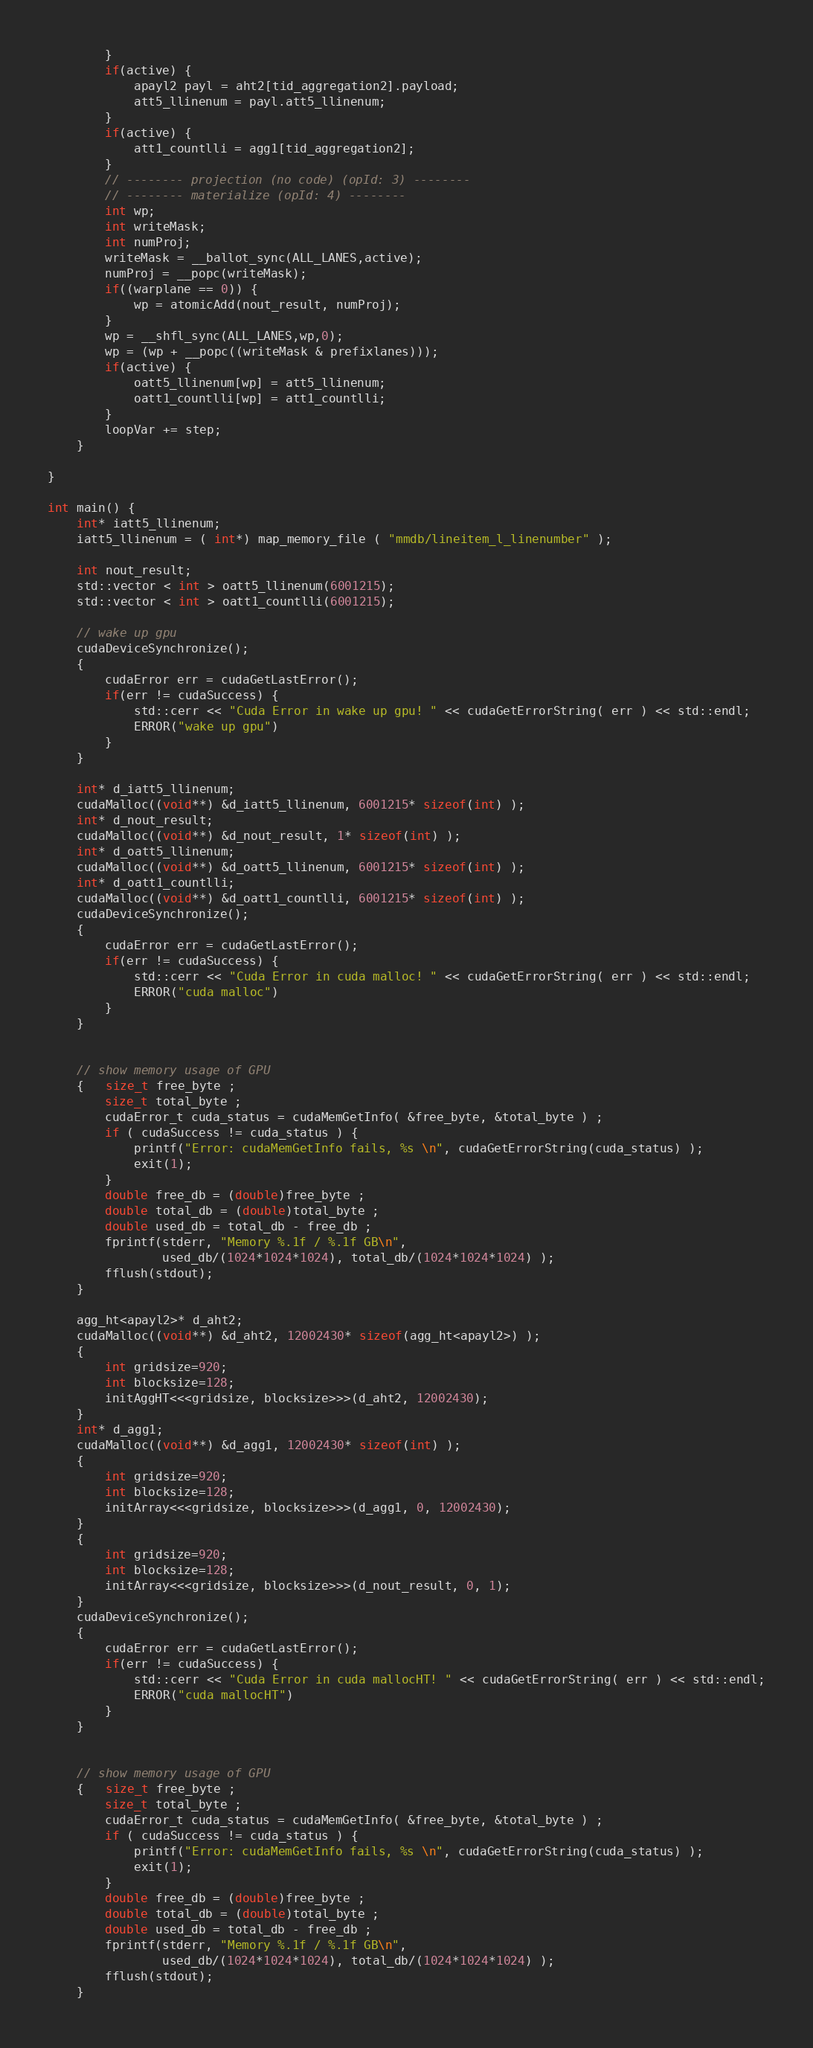Convert code to text. <code><loc_0><loc_0><loc_500><loc_500><_Cuda_>        }
        if(active) {
            apayl2 payl = aht2[tid_aggregation2].payload;
            att5_llinenum = payl.att5_llinenum;
        }
        if(active) {
            att1_countlli = agg1[tid_aggregation2];
        }
        // -------- projection (no code) (opId: 3) --------
        // -------- materialize (opId: 4) --------
        int wp;
        int writeMask;
        int numProj;
        writeMask = __ballot_sync(ALL_LANES,active);
        numProj = __popc(writeMask);
        if((warplane == 0)) {
            wp = atomicAdd(nout_result, numProj);
        }
        wp = __shfl_sync(ALL_LANES,wp,0);
        wp = (wp + __popc((writeMask & prefixlanes)));
        if(active) {
            oatt5_llinenum[wp] = att5_llinenum;
            oatt1_countlli[wp] = att1_countlli;
        }
        loopVar += step;
    }

}

int main() {
    int* iatt5_llinenum;
    iatt5_llinenum = ( int*) map_memory_file ( "mmdb/lineitem_l_linenumber" );

    int nout_result;
    std::vector < int > oatt5_llinenum(6001215);
    std::vector < int > oatt1_countlli(6001215);

    // wake up gpu
    cudaDeviceSynchronize();
    {
        cudaError err = cudaGetLastError();
        if(err != cudaSuccess) {
            std::cerr << "Cuda Error in wake up gpu! " << cudaGetErrorString( err ) << std::endl;
            ERROR("wake up gpu")
        }
    }

    int* d_iatt5_llinenum;
    cudaMalloc((void**) &d_iatt5_llinenum, 6001215* sizeof(int) );
    int* d_nout_result;
    cudaMalloc((void**) &d_nout_result, 1* sizeof(int) );
    int* d_oatt5_llinenum;
    cudaMalloc((void**) &d_oatt5_llinenum, 6001215* sizeof(int) );
    int* d_oatt1_countlli;
    cudaMalloc((void**) &d_oatt1_countlli, 6001215* sizeof(int) );
    cudaDeviceSynchronize();
    {
        cudaError err = cudaGetLastError();
        if(err != cudaSuccess) {
            std::cerr << "Cuda Error in cuda malloc! " << cudaGetErrorString( err ) << std::endl;
            ERROR("cuda malloc")
        }
    }


    // show memory usage of GPU
    {   size_t free_byte ;
        size_t total_byte ;
        cudaError_t cuda_status = cudaMemGetInfo( &free_byte, &total_byte ) ;
        if ( cudaSuccess != cuda_status ) {
            printf("Error: cudaMemGetInfo fails, %s \n", cudaGetErrorString(cuda_status) );
            exit(1);
        }
        double free_db = (double)free_byte ;
        double total_db = (double)total_byte ;
        double used_db = total_db - free_db ;
        fprintf(stderr, "Memory %.1f / %.1f GB\n",
                used_db/(1024*1024*1024), total_db/(1024*1024*1024) );
        fflush(stdout);
    }

    agg_ht<apayl2>* d_aht2;
    cudaMalloc((void**) &d_aht2, 12002430* sizeof(agg_ht<apayl2>) );
    {
        int gridsize=920;
        int blocksize=128;
        initAggHT<<<gridsize, blocksize>>>(d_aht2, 12002430);
    }
    int* d_agg1;
    cudaMalloc((void**) &d_agg1, 12002430* sizeof(int) );
    {
        int gridsize=920;
        int blocksize=128;
        initArray<<<gridsize, blocksize>>>(d_agg1, 0, 12002430);
    }
    {
        int gridsize=920;
        int blocksize=128;
        initArray<<<gridsize, blocksize>>>(d_nout_result, 0, 1);
    }
    cudaDeviceSynchronize();
    {
        cudaError err = cudaGetLastError();
        if(err != cudaSuccess) {
            std::cerr << "Cuda Error in cuda mallocHT! " << cudaGetErrorString( err ) << std::endl;
            ERROR("cuda mallocHT")
        }
    }


    // show memory usage of GPU
    {   size_t free_byte ;
        size_t total_byte ;
        cudaError_t cuda_status = cudaMemGetInfo( &free_byte, &total_byte ) ;
        if ( cudaSuccess != cuda_status ) {
            printf("Error: cudaMemGetInfo fails, %s \n", cudaGetErrorString(cuda_status) );
            exit(1);
        }
        double free_db = (double)free_byte ;
        double total_db = (double)total_byte ;
        double used_db = total_db - free_db ;
        fprintf(stderr, "Memory %.1f / %.1f GB\n",
                used_db/(1024*1024*1024), total_db/(1024*1024*1024) );
        fflush(stdout);
    }
</code> 